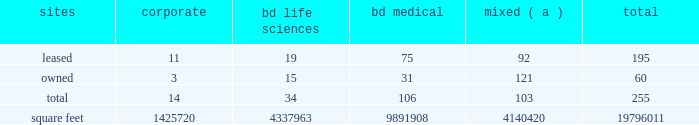The agreements that govern the indebtedness incurred or assumed in connection with the acquisition contain various covenants that impose restrictions on us and certain of our subsidiaries that may affect our ability to operate our businesses .
The agreements that govern the indebtedness incurred or assumed in connection with the carefusion transaction contain various affirmative and negative covenants that may , subject to certain significant exceptions , restrict our ability and the ability of certain of our subsidiaries ( including carefusion ) to , among other things , have liens on their property , transact business with affiliates and/or merge or consolidate with any other person or sell or convey certain of our assets to any one person .
In addition , some of the agreements that govern our indebtedness contain financial covenants that will require us to maintain certain financial ratios .
Our ability and the ability of our subsidiaries to comply with these provisions may be affected by events beyond our control .
Failure to comply with these covenants could result in an event of default , which , if not cured or waived , could accelerate our repayment obligations .
Item 1b .
Unresolved staff comments .
Item 2 .
Properties .
Bd 2019s executive offices are located in franklin lakes , new jersey .
As of october 31 , 2016 , bd owned or leased 255 facilities throughout the world , comprising approximately 19796011 square feet of manufacturing , warehousing , administrative and research facilities .
The u.s .
Facilities , including those in puerto rico , comprise approximately 7459856 square feet of owned and 2923257 square feet of leased space .
The international facilities comprise approximately 7189652 square feet of owned and 2223245 square feet of leased space .
Sales offices and distribution centers included in the total square footage are also located throughout the world .
Operations in each of bd 2019s business segments are conducted at both u.s .
And international locations .
Particularly in the international marketplace , facilities often serve more than one business segment and are used for multiple purposes , such as administrative/sales , manufacturing and/or warehousing/distribution .
Bd generally seeks to own its manufacturing facilities , although some are leased .
The table summarizes property information by business segment. .
( a ) facilities used by more than one business segment .
Bd believes that its facilities are of good construction and in good physical condition , are suitable and adequate for the operations conducted at those facilities , and are , with minor exceptions , fully utilized and operating at normal capacity .
The u.s .
Facilities are located in alabama , arizona , california , connecticut , florida , georgia , illinois , indiana , maryland , massachusetts , michigan , nebraska , new jersey , north carolina , ohio , oklahoma , south carolina , texas , utah , virginia , washington , d.c. , washington , wisconsin and puerto rico .
The international facilities are as follows : - europe , middle east , africa , which includes facilities in austria , belgium , bosnia and herzegovina , the czech republic , denmark , england , finland , france , germany , ghana , hungary , ireland , italy , kenya , luxembourg , netherlands , norway , poland , portugal , russia , saudi arabia , south africa , spain , sweden , switzerland , turkey , the united arab emirates and zambia. .
As of october 31 , 2016 , what was the average square footage for bd owned or leased facilities? 
Computations: (19796011 / 255)
Answer: 77631.41569. 